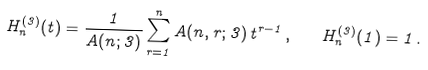<formula> <loc_0><loc_0><loc_500><loc_500>H _ { n } ^ { ( 3 ) } ( t ) = \frac { 1 } { A ( n ; 3 ) } \sum _ { r = 1 } ^ { n } A ( n , r ; 3 ) \, t ^ { r - 1 } \, , \quad H _ { n } ^ { ( 3 ) } ( 1 ) = 1 \, .</formula> 